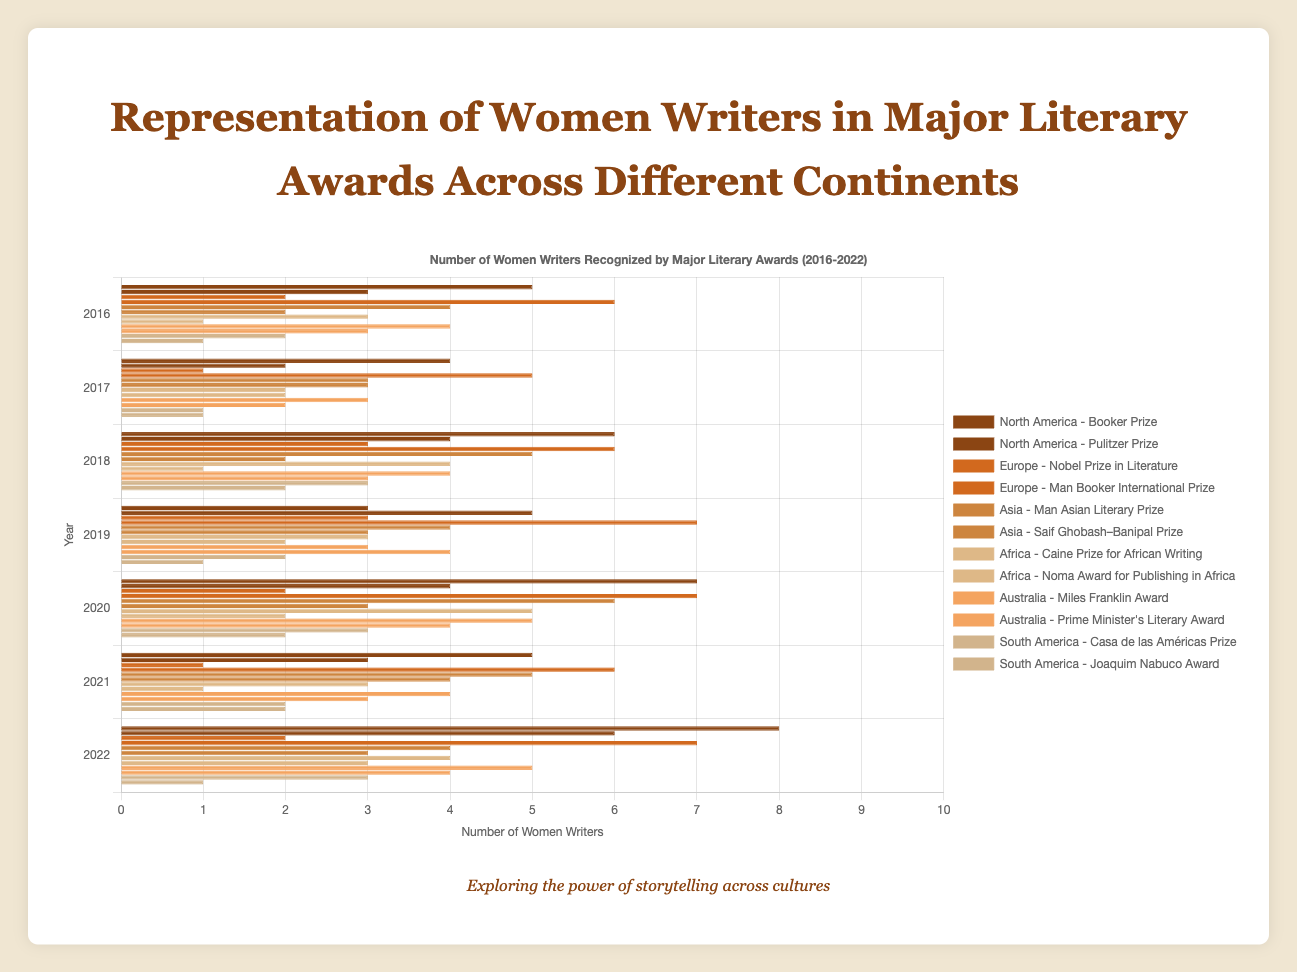Who had the highest representation of women writers in 2022 across all continents and literary awards? Look at the height of the bars in 2022 for each continent and literary award. The highest bar represents North America's Booker Prize with 8 women writers.
Answer: North America's Booker Prize Which continent had the most consistent representation of women writers across all awards from 2016 to 2022? Examine the bars for each continent and notice the variation year by year. Europe shows the most consistent levels in both Nobel Prize in Literature and Man Booker International Prize.
Answer: Europe How did the representation of women writers in Australia's Miles Franklin Award change from 2016 to 2022? Follow the height of the bars for Australia’s Miles Franklin Award from 2016 to 2022: 4, 3, 4, 3, 5, 4, and 5. Note the alternating pattern with a slight increase.
Answer: Increased Compare the representation of women writers between North America's Booker Prize and Pulitzer Prize in 2020. Check the bars for North America in 2020; you will see the Booker Prize has 7 women writers while the Pulitzer Prize has 4.
Answer: Booker Prize What is the difference in the number of women writers between Africa’s Caine Prize and Noma Award for Publishing in Africa in 2019? Look at the bars for Africa in 2019; Caine Prize has 3 and the Noma Award for Publishing in Africa has 2 women writers. The difference is 1.
Answer: 1 Which award recognized the least number of women writers in 2017 across all continents? Identify the shortest bar in 2017 across all awards. The Nobel Prize in Literature in Europe shows the least with 1 woman writer.
Answer: Nobel Prize in Literature What is the total number of women writers recognized by the Man Booker International Prize in Europe from 2016 to 2022? Sum up the number of women writers for the Man Booker International Prize in Europe: 6 + 5 + 6 + 7 + 7 + 6 + 7, which totals 44.
Answer: 44 How does the representation of women writers in the Man Asian Literary Prize in Asia in 2020 compare to 2021? In 2020, the Man Asian Literary Prize in Asia has 6 women writers and in 2021, it has 5. Comparing both values shows it decreased by 1 in 2021.
Answer: Decreased by 1 Which award in South America showed an increase in the number of women writers from 2016 to 2022? Examine each award in South America from 2016 to 2022. The Casa de las Américas Prize increased its count from 2 to 3 women writers.
Answer: Casa de las Américas Prize 